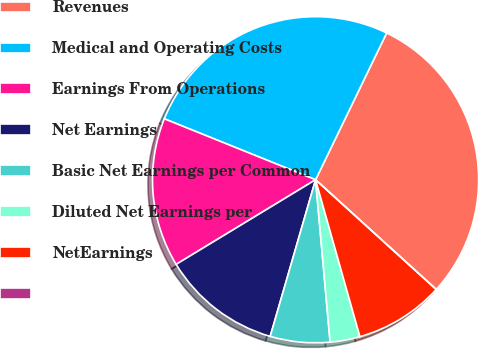Convert chart to OTSL. <chart><loc_0><loc_0><loc_500><loc_500><pie_chart><fcel>Revenues<fcel>Medical and Operating Costs<fcel>Earnings From Operations<fcel>Net Earnings<fcel>Basic Net Earnings per Common<fcel>Diluted Net Earnings per<fcel>NetEarnings<fcel>Unnamed: 7<nl><fcel>29.57%<fcel>26.08%<fcel>14.78%<fcel>11.83%<fcel>5.91%<fcel>2.96%<fcel>8.87%<fcel>0.0%<nl></chart> 